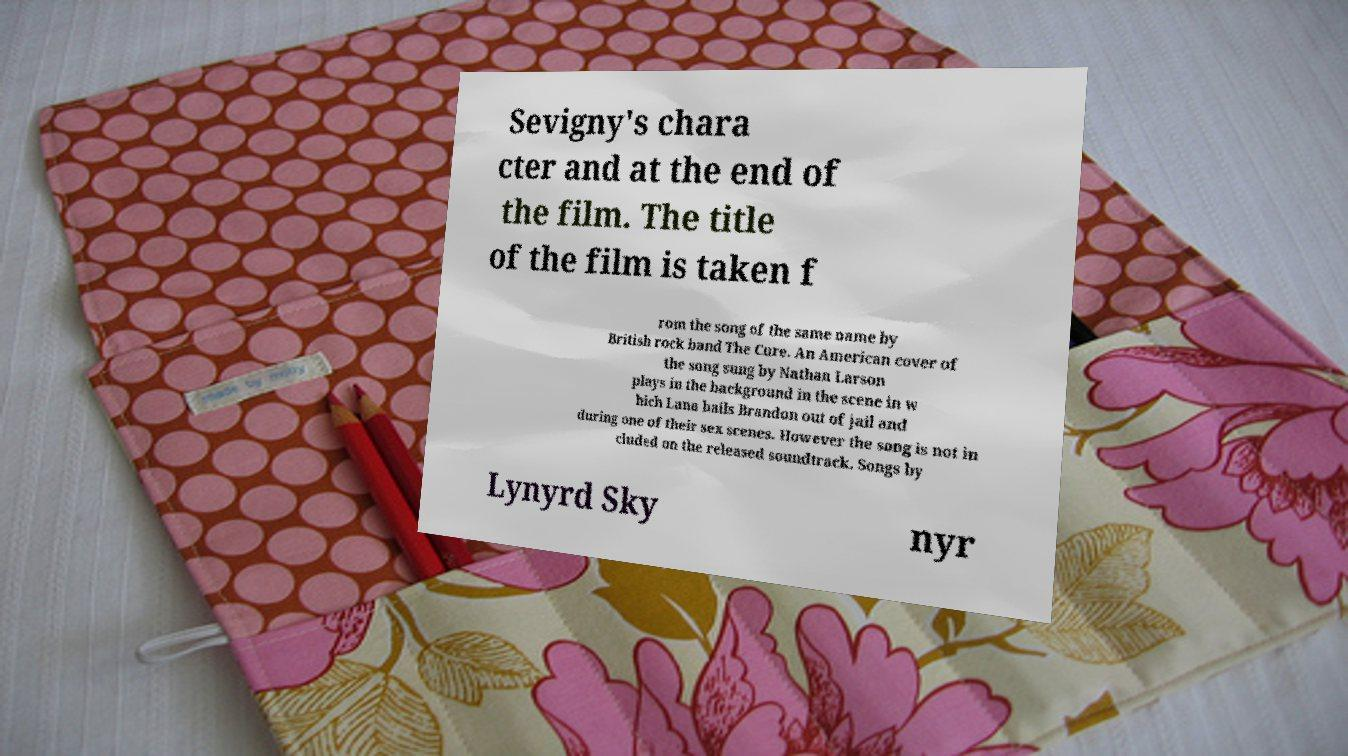Can you accurately transcribe the text from the provided image for me? Sevigny's chara cter and at the end of the film. The title of the film is taken f rom the song of the same name by British rock band The Cure. An American cover of the song sung by Nathan Larson plays in the background in the scene in w hich Lana bails Brandon out of jail and during one of their sex scenes. However the song is not in cluded on the released soundtrack. Songs by Lynyrd Sky nyr 